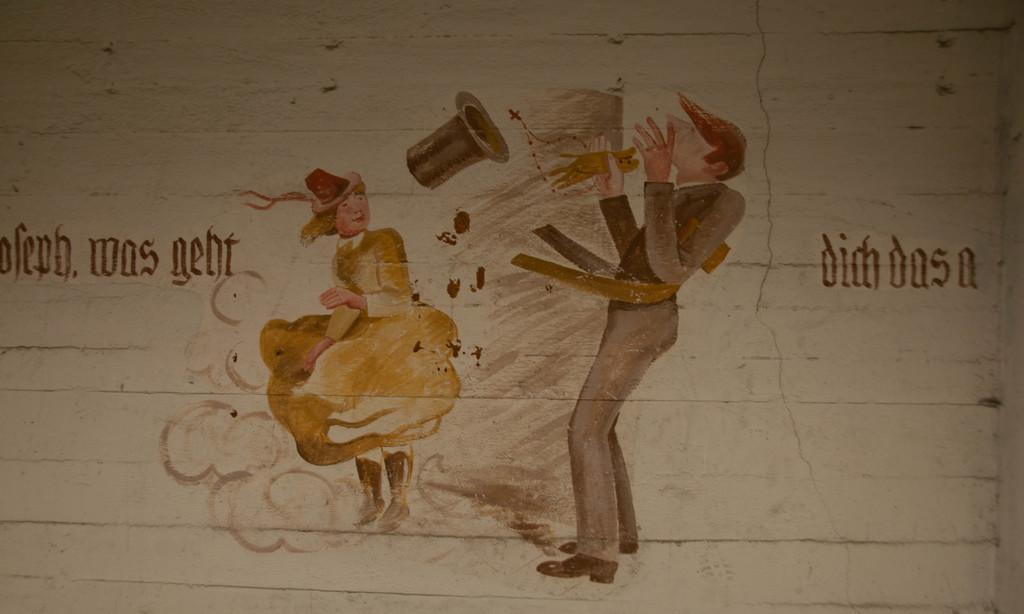What is present on the wall in the image? There is a painting on the wall. What does the painting depict? The painting depicts two people. Are there any specific objects or accessories in the painting? Yes, there is a hat in the center of the painting. Is there any text included in the painting? Yes, there is text in the painting. Can you see a duck wearing a crown in the painting? No, there is no duck or crown present in the painting. The painting depicts two people and a hat, but no duck or crown. 